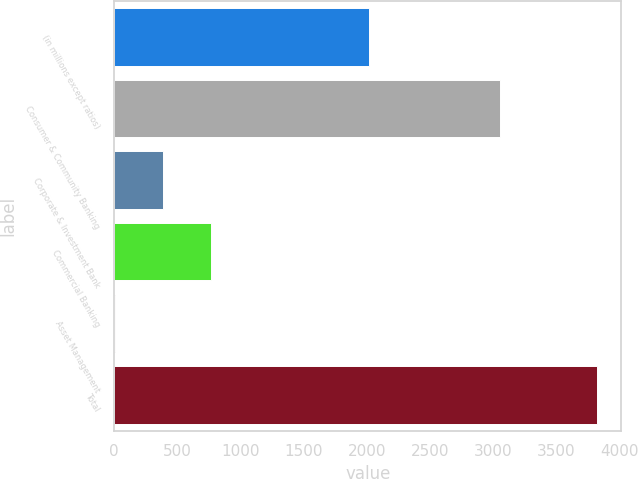Convert chart. <chart><loc_0><loc_0><loc_500><loc_500><bar_chart><fcel>(in millions except ratios)<fcel>Consumer & Community Banking<fcel>Corporate & Investment Bank<fcel>Commercial Banking<fcel>Asset Management<fcel>Total<nl><fcel>2015<fcel>3059<fcel>386.3<fcel>768.6<fcel>4<fcel>3827<nl></chart> 